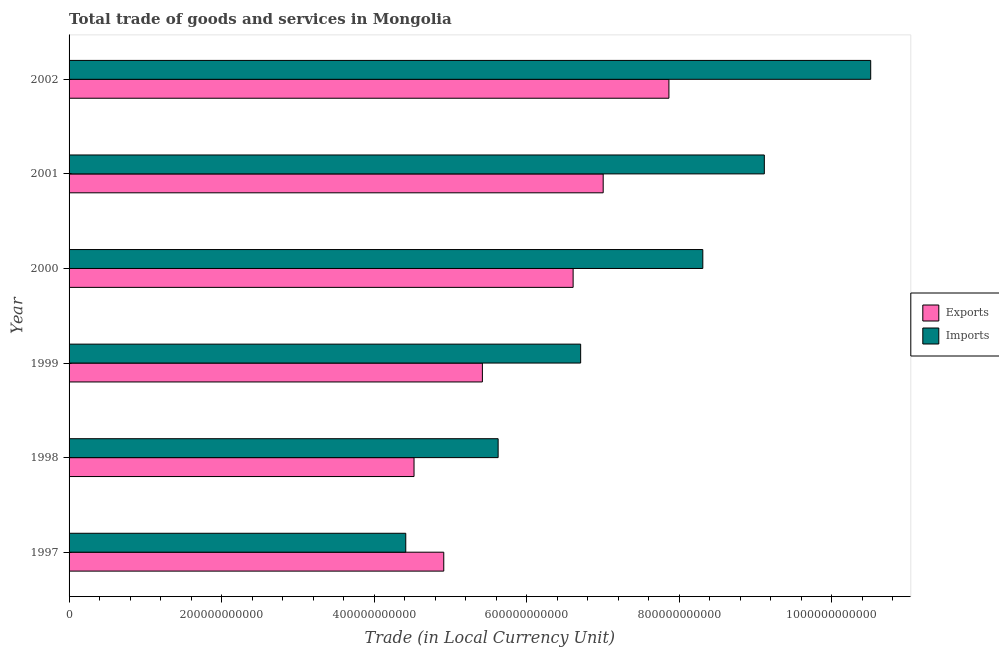How many different coloured bars are there?
Your answer should be compact. 2. How many groups of bars are there?
Your answer should be very brief. 6. Are the number of bars per tick equal to the number of legend labels?
Your response must be concise. Yes. Are the number of bars on each tick of the Y-axis equal?
Offer a terse response. Yes. How many bars are there on the 5th tick from the top?
Offer a very short reply. 2. What is the label of the 4th group of bars from the top?
Your answer should be compact. 1999. In how many cases, is the number of bars for a given year not equal to the number of legend labels?
Provide a succinct answer. 0. What is the imports of goods and services in 2001?
Offer a very short reply. 9.12e+11. Across all years, what is the maximum imports of goods and services?
Your answer should be compact. 1.05e+12. Across all years, what is the minimum export of goods and services?
Give a very brief answer. 4.52e+11. In which year was the export of goods and services maximum?
Make the answer very short. 2002. What is the total imports of goods and services in the graph?
Your response must be concise. 4.47e+12. What is the difference between the export of goods and services in 1999 and that in 2002?
Provide a short and direct response. -2.45e+11. What is the difference between the export of goods and services in 1998 and the imports of goods and services in 2001?
Provide a short and direct response. -4.59e+11. What is the average imports of goods and services per year?
Offer a terse response. 7.45e+11. In the year 1999, what is the difference between the imports of goods and services and export of goods and services?
Offer a terse response. 1.29e+11. In how many years, is the imports of goods and services greater than 1000000000000 LCU?
Provide a succinct answer. 1. What is the ratio of the export of goods and services in 1997 to that in 1998?
Give a very brief answer. 1.09. What is the difference between the highest and the second highest export of goods and services?
Your response must be concise. 8.62e+1. What is the difference between the highest and the lowest imports of goods and services?
Your answer should be compact. 6.10e+11. In how many years, is the imports of goods and services greater than the average imports of goods and services taken over all years?
Your response must be concise. 3. Is the sum of the imports of goods and services in 1998 and 2000 greater than the maximum export of goods and services across all years?
Offer a very short reply. Yes. What does the 2nd bar from the top in 2000 represents?
Provide a succinct answer. Exports. What does the 2nd bar from the bottom in 1998 represents?
Offer a terse response. Imports. Are all the bars in the graph horizontal?
Your answer should be very brief. Yes. What is the difference between two consecutive major ticks on the X-axis?
Ensure brevity in your answer.  2.00e+11. Are the values on the major ticks of X-axis written in scientific E-notation?
Offer a very short reply. No. Where does the legend appear in the graph?
Offer a terse response. Center right. What is the title of the graph?
Keep it short and to the point. Total trade of goods and services in Mongolia. Does "Foreign liabilities" appear as one of the legend labels in the graph?
Keep it short and to the point. No. What is the label or title of the X-axis?
Your response must be concise. Trade (in Local Currency Unit). What is the Trade (in Local Currency Unit) of Exports in 1997?
Provide a short and direct response. 4.91e+11. What is the Trade (in Local Currency Unit) in Imports in 1997?
Provide a succinct answer. 4.42e+11. What is the Trade (in Local Currency Unit) of Exports in 1998?
Keep it short and to the point. 4.52e+11. What is the Trade (in Local Currency Unit) of Imports in 1998?
Make the answer very short. 5.63e+11. What is the Trade (in Local Currency Unit) in Exports in 1999?
Your answer should be very brief. 5.42e+11. What is the Trade (in Local Currency Unit) in Imports in 1999?
Offer a terse response. 6.71e+11. What is the Trade (in Local Currency Unit) of Exports in 2000?
Offer a very short reply. 6.61e+11. What is the Trade (in Local Currency Unit) in Imports in 2000?
Offer a terse response. 8.31e+11. What is the Trade (in Local Currency Unit) of Exports in 2001?
Your answer should be compact. 7.00e+11. What is the Trade (in Local Currency Unit) of Imports in 2001?
Give a very brief answer. 9.12e+11. What is the Trade (in Local Currency Unit) of Exports in 2002?
Provide a short and direct response. 7.87e+11. What is the Trade (in Local Currency Unit) of Imports in 2002?
Your answer should be compact. 1.05e+12. Across all years, what is the maximum Trade (in Local Currency Unit) of Exports?
Offer a very short reply. 7.87e+11. Across all years, what is the maximum Trade (in Local Currency Unit) of Imports?
Offer a terse response. 1.05e+12. Across all years, what is the minimum Trade (in Local Currency Unit) in Exports?
Give a very brief answer. 4.52e+11. Across all years, what is the minimum Trade (in Local Currency Unit) of Imports?
Your answer should be very brief. 4.42e+11. What is the total Trade (in Local Currency Unit) of Exports in the graph?
Offer a very short reply. 3.63e+12. What is the total Trade (in Local Currency Unit) in Imports in the graph?
Offer a terse response. 4.47e+12. What is the difference between the Trade (in Local Currency Unit) in Exports in 1997 and that in 1998?
Keep it short and to the point. 3.90e+1. What is the difference between the Trade (in Local Currency Unit) of Imports in 1997 and that in 1998?
Provide a succinct answer. -1.21e+11. What is the difference between the Trade (in Local Currency Unit) in Exports in 1997 and that in 1999?
Your answer should be compact. -5.06e+1. What is the difference between the Trade (in Local Currency Unit) of Imports in 1997 and that in 1999?
Keep it short and to the point. -2.29e+11. What is the difference between the Trade (in Local Currency Unit) in Exports in 1997 and that in 2000?
Your response must be concise. -1.70e+11. What is the difference between the Trade (in Local Currency Unit) in Imports in 1997 and that in 2000?
Your answer should be compact. -3.90e+11. What is the difference between the Trade (in Local Currency Unit) in Exports in 1997 and that in 2001?
Provide a succinct answer. -2.09e+11. What is the difference between the Trade (in Local Currency Unit) in Imports in 1997 and that in 2001?
Provide a short and direct response. -4.70e+11. What is the difference between the Trade (in Local Currency Unit) of Exports in 1997 and that in 2002?
Provide a succinct answer. -2.95e+11. What is the difference between the Trade (in Local Currency Unit) in Imports in 1997 and that in 2002?
Your answer should be very brief. -6.10e+11. What is the difference between the Trade (in Local Currency Unit) in Exports in 1998 and that in 1999?
Your response must be concise. -8.96e+1. What is the difference between the Trade (in Local Currency Unit) in Imports in 1998 and that in 1999?
Make the answer very short. -1.08e+11. What is the difference between the Trade (in Local Currency Unit) in Exports in 1998 and that in 2000?
Offer a terse response. -2.09e+11. What is the difference between the Trade (in Local Currency Unit) in Imports in 1998 and that in 2000?
Give a very brief answer. -2.68e+11. What is the difference between the Trade (in Local Currency Unit) of Exports in 1998 and that in 2001?
Give a very brief answer. -2.48e+11. What is the difference between the Trade (in Local Currency Unit) of Imports in 1998 and that in 2001?
Your response must be concise. -3.49e+11. What is the difference between the Trade (in Local Currency Unit) in Exports in 1998 and that in 2002?
Provide a short and direct response. -3.34e+11. What is the difference between the Trade (in Local Currency Unit) of Imports in 1998 and that in 2002?
Make the answer very short. -4.89e+11. What is the difference between the Trade (in Local Currency Unit) of Exports in 1999 and that in 2000?
Provide a short and direct response. -1.19e+11. What is the difference between the Trade (in Local Currency Unit) of Imports in 1999 and that in 2000?
Offer a very short reply. -1.60e+11. What is the difference between the Trade (in Local Currency Unit) of Exports in 1999 and that in 2001?
Provide a succinct answer. -1.58e+11. What is the difference between the Trade (in Local Currency Unit) in Imports in 1999 and that in 2001?
Provide a short and direct response. -2.41e+11. What is the difference between the Trade (in Local Currency Unit) in Exports in 1999 and that in 2002?
Offer a terse response. -2.45e+11. What is the difference between the Trade (in Local Currency Unit) of Imports in 1999 and that in 2002?
Provide a succinct answer. -3.80e+11. What is the difference between the Trade (in Local Currency Unit) in Exports in 2000 and that in 2001?
Make the answer very short. -3.94e+1. What is the difference between the Trade (in Local Currency Unit) of Imports in 2000 and that in 2001?
Your answer should be very brief. -8.07e+1. What is the difference between the Trade (in Local Currency Unit) of Exports in 2000 and that in 2002?
Keep it short and to the point. -1.26e+11. What is the difference between the Trade (in Local Currency Unit) in Imports in 2000 and that in 2002?
Offer a very short reply. -2.20e+11. What is the difference between the Trade (in Local Currency Unit) of Exports in 2001 and that in 2002?
Offer a very short reply. -8.62e+1. What is the difference between the Trade (in Local Currency Unit) of Imports in 2001 and that in 2002?
Your response must be concise. -1.39e+11. What is the difference between the Trade (in Local Currency Unit) in Exports in 1997 and the Trade (in Local Currency Unit) in Imports in 1998?
Your answer should be very brief. -7.13e+1. What is the difference between the Trade (in Local Currency Unit) of Exports in 1997 and the Trade (in Local Currency Unit) of Imports in 1999?
Give a very brief answer. -1.79e+11. What is the difference between the Trade (in Local Currency Unit) of Exports in 1997 and the Trade (in Local Currency Unit) of Imports in 2000?
Provide a succinct answer. -3.40e+11. What is the difference between the Trade (in Local Currency Unit) of Exports in 1997 and the Trade (in Local Currency Unit) of Imports in 2001?
Offer a terse response. -4.20e+11. What is the difference between the Trade (in Local Currency Unit) in Exports in 1997 and the Trade (in Local Currency Unit) in Imports in 2002?
Offer a terse response. -5.60e+11. What is the difference between the Trade (in Local Currency Unit) in Exports in 1998 and the Trade (in Local Currency Unit) in Imports in 1999?
Provide a succinct answer. -2.18e+11. What is the difference between the Trade (in Local Currency Unit) in Exports in 1998 and the Trade (in Local Currency Unit) in Imports in 2000?
Keep it short and to the point. -3.79e+11. What is the difference between the Trade (in Local Currency Unit) of Exports in 1998 and the Trade (in Local Currency Unit) of Imports in 2001?
Give a very brief answer. -4.59e+11. What is the difference between the Trade (in Local Currency Unit) in Exports in 1998 and the Trade (in Local Currency Unit) in Imports in 2002?
Offer a very short reply. -5.99e+11. What is the difference between the Trade (in Local Currency Unit) in Exports in 1999 and the Trade (in Local Currency Unit) in Imports in 2000?
Give a very brief answer. -2.89e+11. What is the difference between the Trade (in Local Currency Unit) of Exports in 1999 and the Trade (in Local Currency Unit) of Imports in 2001?
Keep it short and to the point. -3.70e+11. What is the difference between the Trade (in Local Currency Unit) of Exports in 1999 and the Trade (in Local Currency Unit) of Imports in 2002?
Make the answer very short. -5.09e+11. What is the difference between the Trade (in Local Currency Unit) in Exports in 2000 and the Trade (in Local Currency Unit) in Imports in 2001?
Your response must be concise. -2.51e+11. What is the difference between the Trade (in Local Currency Unit) of Exports in 2000 and the Trade (in Local Currency Unit) of Imports in 2002?
Provide a short and direct response. -3.90e+11. What is the difference between the Trade (in Local Currency Unit) of Exports in 2001 and the Trade (in Local Currency Unit) of Imports in 2002?
Make the answer very short. -3.51e+11. What is the average Trade (in Local Currency Unit) in Exports per year?
Provide a succinct answer. 6.06e+11. What is the average Trade (in Local Currency Unit) of Imports per year?
Make the answer very short. 7.45e+11. In the year 1997, what is the difference between the Trade (in Local Currency Unit) of Exports and Trade (in Local Currency Unit) of Imports?
Give a very brief answer. 4.98e+1. In the year 1998, what is the difference between the Trade (in Local Currency Unit) of Exports and Trade (in Local Currency Unit) of Imports?
Your answer should be very brief. -1.10e+11. In the year 1999, what is the difference between the Trade (in Local Currency Unit) in Exports and Trade (in Local Currency Unit) in Imports?
Make the answer very short. -1.29e+11. In the year 2000, what is the difference between the Trade (in Local Currency Unit) of Exports and Trade (in Local Currency Unit) of Imports?
Your answer should be very brief. -1.70e+11. In the year 2001, what is the difference between the Trade (in Local Currency Unit) in Exports and Trade (in Local Currency Unit) in Imports?
Keep it short and to the point. -2.11e+11. In the year 2002, what is the difference between the Trade (in Local Currency Unit) of Exports and Trade (in Local Currency Unit) of Imports?
Your response must be concise. -2.65e+11. What is the ratio of the Trade (in Local Currency Unit) of Exports in 1997 to that in 1998?
Offer a terse response. 1.09. What is the ratio of the Trade (in Local Currency Unit) in Imports in 1997 to that in 1998?
Your response must be concise. 0.78. What is the ratio of the Trade (in Local Currency Unit) in Exports in 1997 to that in 1999?
Keep it short and to the point. 0.91. What is the ratio of the Trade (in Local Currency Unit) of Imports in 1997 to that in 1999?
Your answer should be compact. 0.66. What is the ratio of the Trade (in Local Currency Unit) of Exports in 1997 to that in 2000?
Provide a short and direct response. 0.74. What is the ratio of the Trade (in Local Currency Unit) of Imports in 1997 to that in 2000?
Offer a terse response. 0.53. What is the ratio of the Trade (in Local Currency Unit) in Exports in 1997 to that in 2001?
Offer a terse response. 0.7. What is the ratio of the Trade (in Local Currency Unit) in Imports in 1997 to that in 2001?
Provide a short and direct response. 0.48. What is the ratio of the Trade (in Local Currency Unit) of Exports in 1997 to that in 2002?
Your response must be concise. 0.62. What is the ratio of the Trade (in Local Currency Unit) in Imports in 1997 to that in 2002?
Make the answer very short. 0.42. What is the ratio of the Trade (in Local Currency Unit) of Exports in 1998 to that in 1999?
Your answer should be very brief. 0.83. What is the ratio of the Trade (in Local Currency Unit) of Imports in 1998 to that in 1999?
Offer a terse response. 0.84. What is the ratio of the Trade (in Local Currency Unit) of Exports in 1998 to that in 2000?
Ensure brevity in your answer.  0.68. What is the ratio of the Trade (in Local Currency Unit) of Imports in 1998 to that in 2000?
Keep it short and to the point. 0.68. What is the ratio of the Trade (in Local Currency Unit) in Exports in 1998 to that in 2001?
Your answer should be compact. 0.65. What is the ratio of the Trade (in Local Currency Unit) of Imports in 1998 to that in 2001?
Give a very brief answer. 0.62. What is the ratio of the Trade (in Local Currency Unit) in Exports in 1998 to that in 2002?
Provide a succinct answer. 0.58. What is the ratio of the Trade (in Local Currency Unit) in Imports in 1998 to that in 2002?
Ensure brevity in your answer.  0.54. What is the ratio of the Trade (in Local Currency Unit) of Exports in 1999 to that in 2000?
Your answer should be very brief. 0.82. What is the ratio of the Trade (in Local Currency Unit) of Imports in 1999 to that in 2000?
Offer a very short reply. 0.81. What is the ratio of the Trade (in Local Currency Unit) in Exports in 1999 to that in 2001?
Keep it short and to the point. 0.77. What is the ratio of the Trade (in Local Currency Unit) of Imports in 1999 to that in 2001?
Provide a short and direct response. 0.74. What is the ratio of the Trade (in Local Currency Unit) in Exports in 1999 to that in 2002?
Your response must be concise. 0.69. What is the ratio of the Trade (in Local Currency Unit) of Imports in 1999 to that in 2002?
Your response must be concise. 0.64. What is the ratio of the Trade (in Local Currency Unit) of Exports in 2000 to that in 2001?
Offer a terse response. 0.94. What is the ratio of the Trade (in Local Currency Unit) in Imports in 2000 to that in 2001?
Offer a very short reply. 0.91. What is the ratio of the Trade (in Local Currency Unit) of Exports in 2000 to that in 2002?
Make the answer very short. 0.84. What is the ratio of the Trade (in Local Currency Unit) of Imports in 2000 to that in 2002?
Make the answer very short. 0.79. What is the ratio of the Trade (in Local Currency Unit) in Exports in 2001 to that in 2002?
Offer a very short reply. 0.89. What is the ratio of the Trade (in Local Currency Unit) in Imports in 2001 to that in 2002?
Your response must be concise. 0.87. What is the difference between the highest and the second highest Trade (in Local Currency Unit) in Exports?
Offer a very short reply. 8.62e+1. What is the difference between the highest and the second highest Trade (in Local Currency Unit) in Imports?
Give a very brief answer. 1.39e+11. What is the difference between the highest and the lowest Trade (in Local Currency Unit) in Exports?
Your answer should be very brief. 3.34e+11. What is the difference between the highest and the lowest Trade (in Local Currency Unit) in Imports?
Offer a terse response. 6.10e+11. 